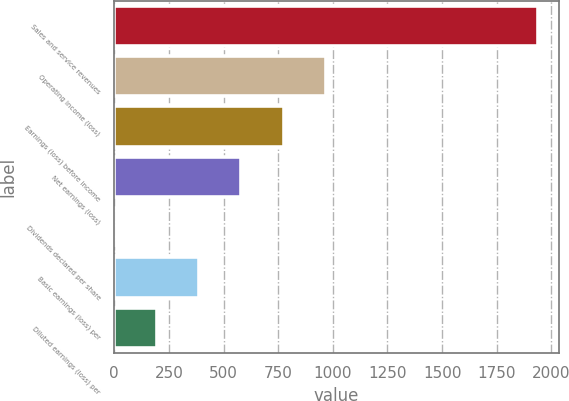Convert chart. <chart><loc_0><loc_0><loc_500><loc_500><bar_chart><fcel>Sales and service revenues<fcel>Operating income (loss)<fcel>Earnings (loss) before income<fcel>Net earnings (loss)<fcel>Dividends declared per share<fcel>Basic earnings (loss) per<fcel>Diluted earnings (loss) per<nl><fcel>1938<fcel>969.1<fcel>775.32<fcel>581.54<fcel>0.2<fcel>387.76<fcel>193.98<nl></chart> 